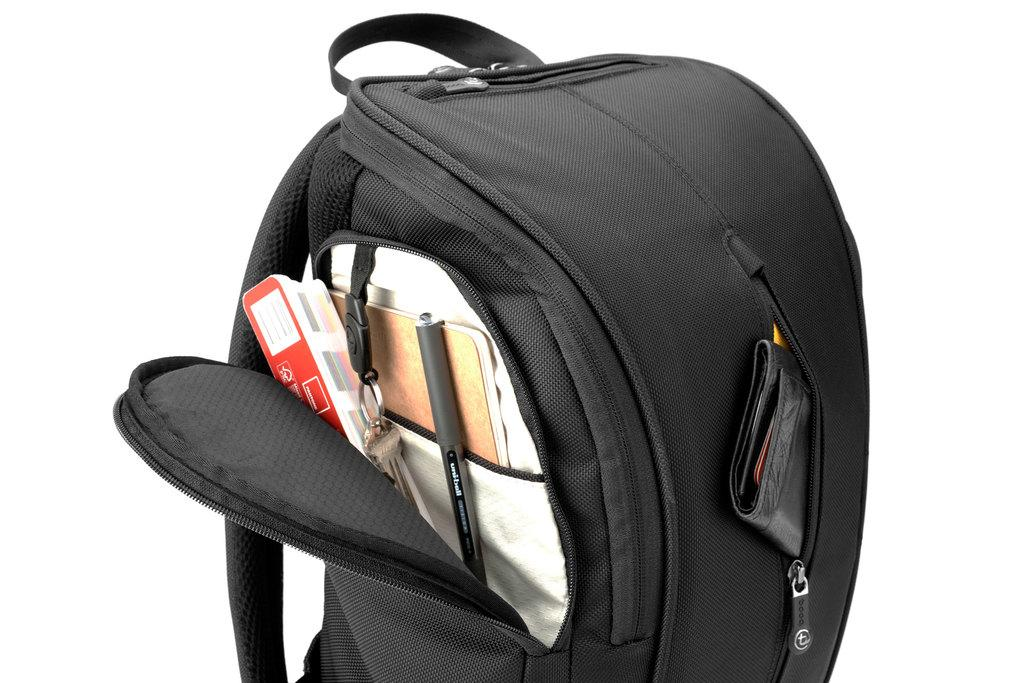What is the color of the bag in the image? The bag in the image is black. What items can be found inside the black bag? There is a pen and a box in the black bag. Who is the girl holding the bat in the image? There is no girl or bat present in the image; it only features a black bag with a pen and a box inside. 